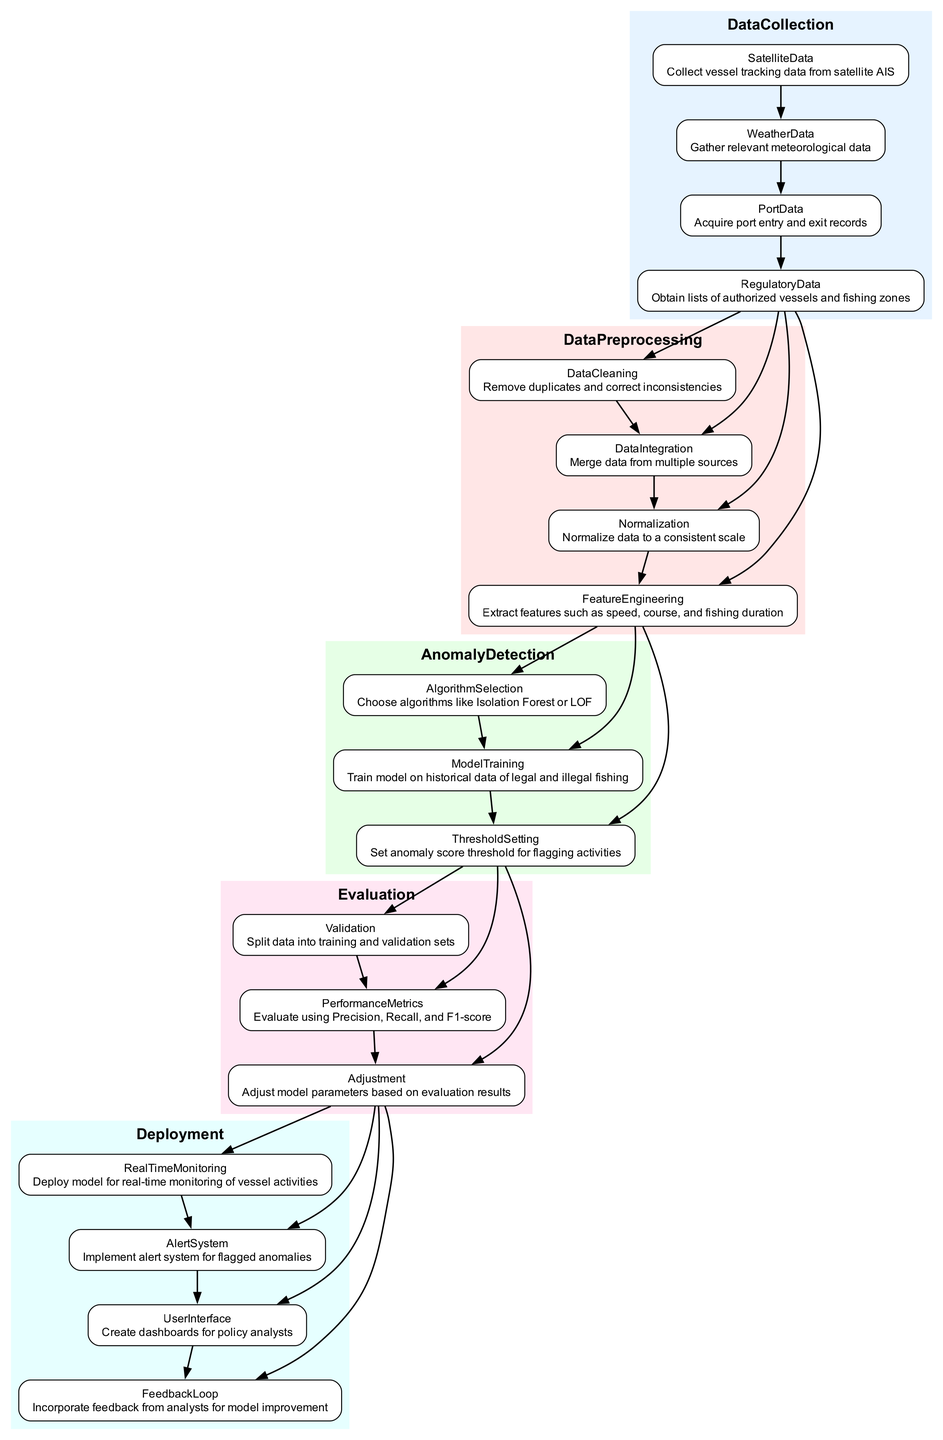What are the data sources used for Data Collection? The Data Collection step involves collecting tracking information from satellite AIS, gathering weather data, acquiring port entry and exit records, and obtaining lists of authorized vessels and fishing zones. These specific sources are clearly outlined in the diagram under the Data Collection section.
Answer: Satellite data, Weather data, Port data, Regulatory data How many steps are involved in Data Preprocessing? The Data Preprocessing section contains four distinct steps, as indicated in the diagram: Data Cleaning, Data Integration, Normalization, and Feature Engineering. By counting the listed items, we arrive at the total number of steps.
Answer: Four Which algorithm is suggested for Anomaly Detection? The diagram specifies that algorithms like Isolation Forest or LOF can be chosen for Anomaly Detection. This information is found within the Anomaly Detection section, highlighting the available options for algorithm selection.
Answer: Isolation Forest or LOF What is the purpose of the Feedback Loop in Deployment? The Feedback Loop is intended for incorporating feedback from analysts to improve the model. This explanation is derived from the context presented in the Deployment section where this step is framed as a mechanism for continuous enhancement of the monitoring system.
Answer: Improve model What is evaluated in the Evaluation phase? During the Evaluation phase, the performance of the model is assessed using Precision, Recall, and F1-score as metrics. This is explicitly stated in the Evaluation section of the diagram, indicating the performance measures that will be evaluated.
Answer: Precision, Recall, F1-score What is the final step in the Anomaly Detection process? The final step in the Anomaly Detection process is Threshold Setting, which is the last sub-step listed under Anomaly Detection in the diagram. By referring to the sequence of steps, we identify that this is the concluding action in this segment.
Answer: Threshold Setting How is the model deployed for monitoring? The model is deployed for real-time monitoring of vessel activities. This information is specified in the Deployment section and highlights the main objective of deploying the machine learning model after its training and evaluation.
Answer: Real-time monitoring What type of system is implemented for flagged anomalies? An alert system is implemented for flagged anomalies. This is indicated in the Deployment section, which points out the need for a system to notify stakeholders about anomalies detected by the model.
Answer: Alert system Which step comes after Model Training in Anomaly Detection? Threshold Setting comes after Model Training in the Anomaly Detection segment. By following the flow of the diagram sequentially from one step to the next, this conclusion is determined.
Answer: Threshold Setting 